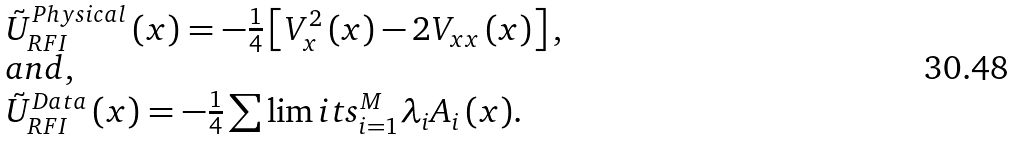Convert formula to latex. <formula><loc_0><loc_0><loc_500><loc_500>\begin{array} { l } \tilde { U } _ { R F I } ^ { P h y s i c a l } \left ( x \right ) = - \frac { 1 } { 4 } \left [ { V _ { x } ^ { 2 } \left ( x \right ) - 2 V _ { x x } \left ( x \right ) } \right ] , \\ a n d , \\ \tilde { U } _ { R F I } ^ { D a t a } \left ( x \right ) = - \frac { 1 } { 4 } \sum \lim i t s _ { i = 1 } ^ { M } { \lambda _ { i } A _ { i } \left ( x \right ) } . \\ \end{array}</formula> 